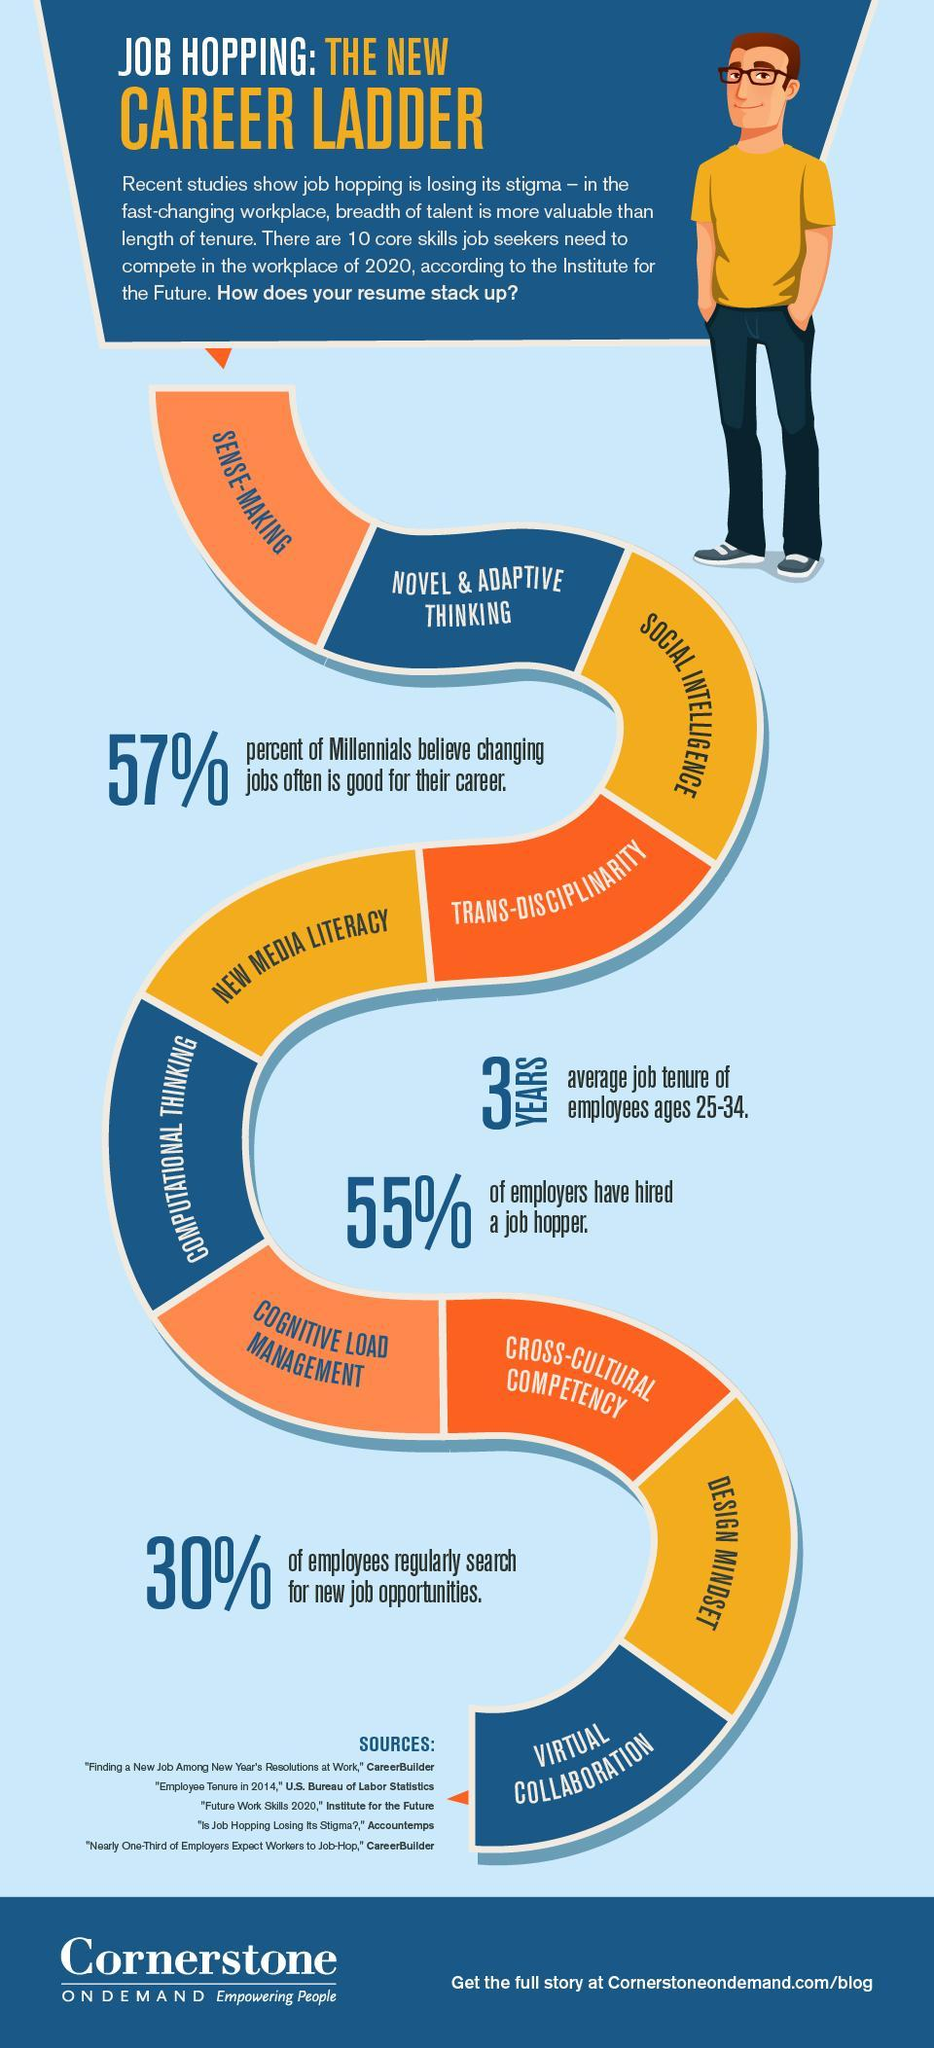What percentage of people does not believe that changing jobs is good for their career?
Answer the question with a short phrase. 43 What percentage of employees do not search for new job openings regularly? 70 What percentage of employers have not hired a job hopper? 45 